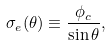<formula> <loc_0><loc_0><loc_500><loc_500>\sigma _ { e } ( \theta ) \equiv \frac { \phi _ { c } } { \sin \theta } ,</formula> 